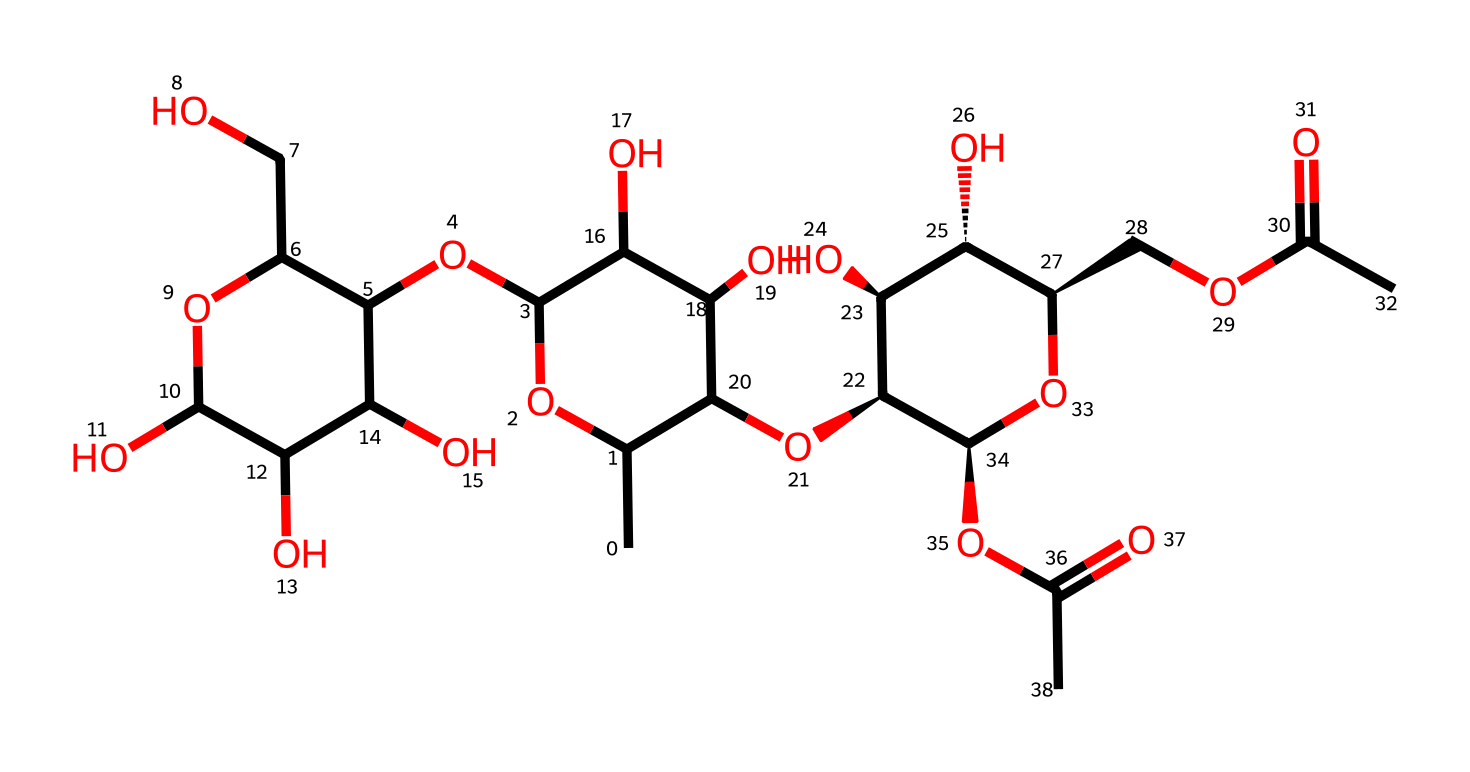What is the name of this polymer? The structure corresponds to pectin, which is a polysaccharide commonly found in fruits. The repeating units in the structure indicate its identity as a polymer.
Answer: pectin How many carbon atoms are in this polymer? By counting the carbon atoms in the SMILES representation, there are 19 carbon atoms present overall in the structure of pectin.
Answer: 19 What type of linkage is predominantly found in this polymer? The structure contains glycosidic linkages, as indicated by the ether bonds between the sugar units in the polysaccharide chain.
Answer: glycosidic Does this polymer have branching in its structure? The presence of multiple sugar units connected by different linkages suggests that there is some branching in the pectin structure, especially with the side chains indicated.
Answer: yes What functional groups are present in this polymer? The structure reveals hydroxyl (-OH) groups appearing frequently, which are characteristic of pectin, along with carboxylic acid groups from the esterifications.
Answer: hydroxyl, carboxylic acid How does the degree of methylation affect this polymer? The degree of methylation can influence the gelling properties of pectin. The structure suggests the presence of methoxy groups, which affect gel formation when combined with sugar and acid.
Answer: affects gelling 